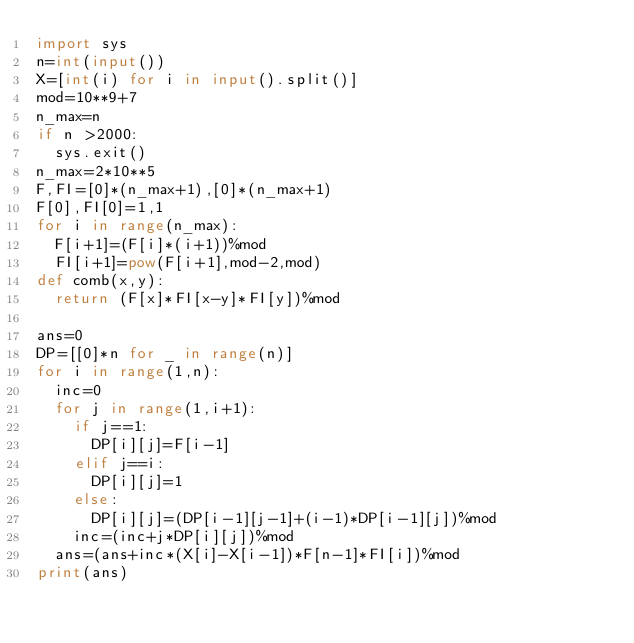Convert code to text. <code><loc_0><loc_0><loc_500><loc_500><_Python_>import sys
n=int(input())
X=[int(i) for i in input().split()]
mod=10**9+7
n_max=n
if n >2000:
  sys.exit()
n_max=2*10**5
F,FI=[0]*(n_max+1),[0]*(n_max+1)
F[0],FI[0]=1,1
for i in range(n_max):
  F[i+1]=(F[i]*(i+1))%mod
  FI[i+1]=pow(F[i+1],mod-2,mod)
def comb(x,y):
  return (F[x]*FI[x-y]*FI[y])%mod

ans=0
DP=[[0]*n for _ in range(n)]
for i in range(1,n):
  inc=0
  for j in range(1,i+1):
    if j==1:
      DP[i][j]=F[i-1]
    elif j==i:
      DP[i][j]=1
    else:
      DP[i][j]=(DP[i-1][j-1]+(i-1)*DP[i-1][j])%mod
    inc=(inc+j*DP[i][j])%mod
  ans=(ans+inc*(X[i]-X[i-1])*F[n-1]*FI[i])%mod
print(ans)
</code> 